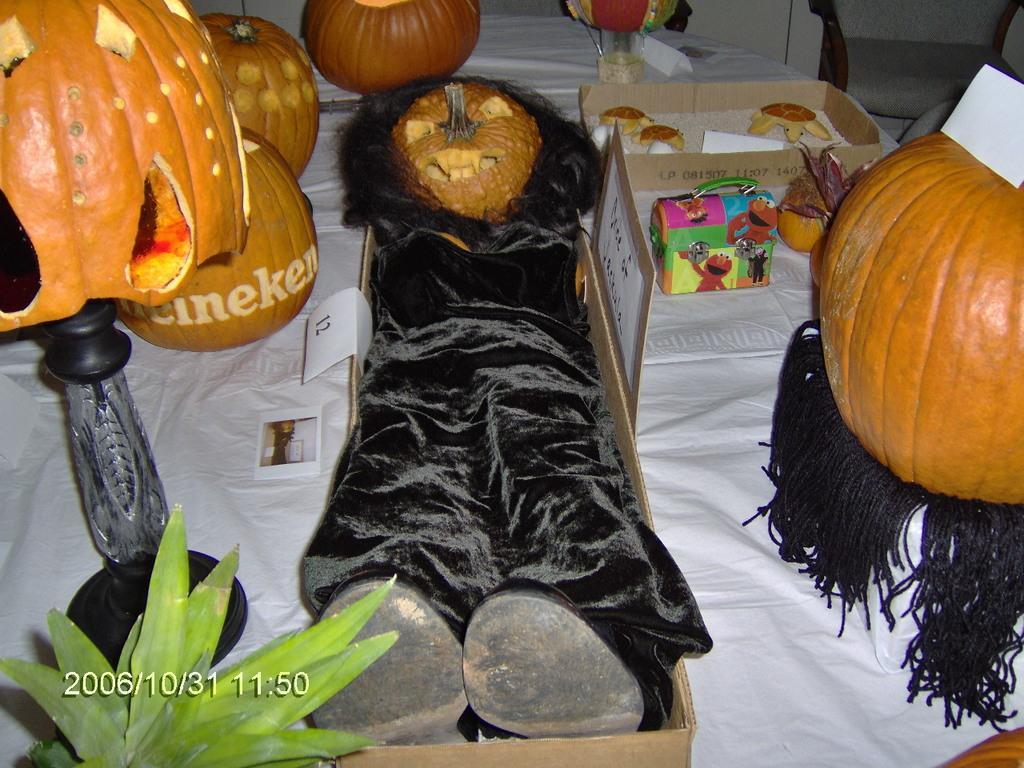Can you describe this image briefly? In this image there are pumpkins, papers, lamp stand, cloth ,wig , shoes, plant, cardboard boxes, sand, glass, tortoises on the white color cloth , and at the background there is a chair , and a watermark on the image. 